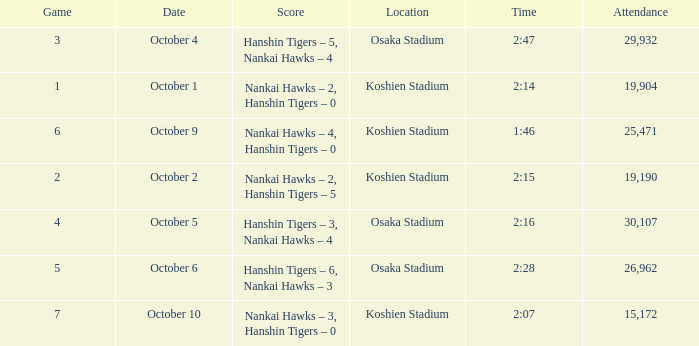Which Score has a Time of 2:28? Hanshin Tigers – 6, Nankai Hawks – 3. 